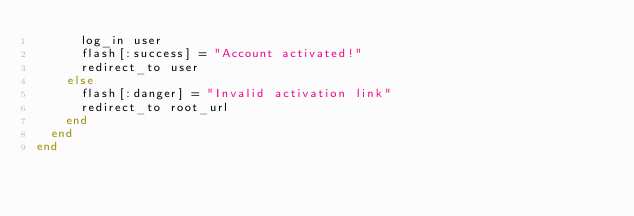Convert code to text. <code><loc_0><loc_0><loc_500><loc_500><_Ruby_>      log_in user
      flash[:success] = "Account activated!"
      redirect_to user
    else
      flash[:danger] = "Invalid activation link"
      redirect_to root_url
    end
  end
end
</code> 